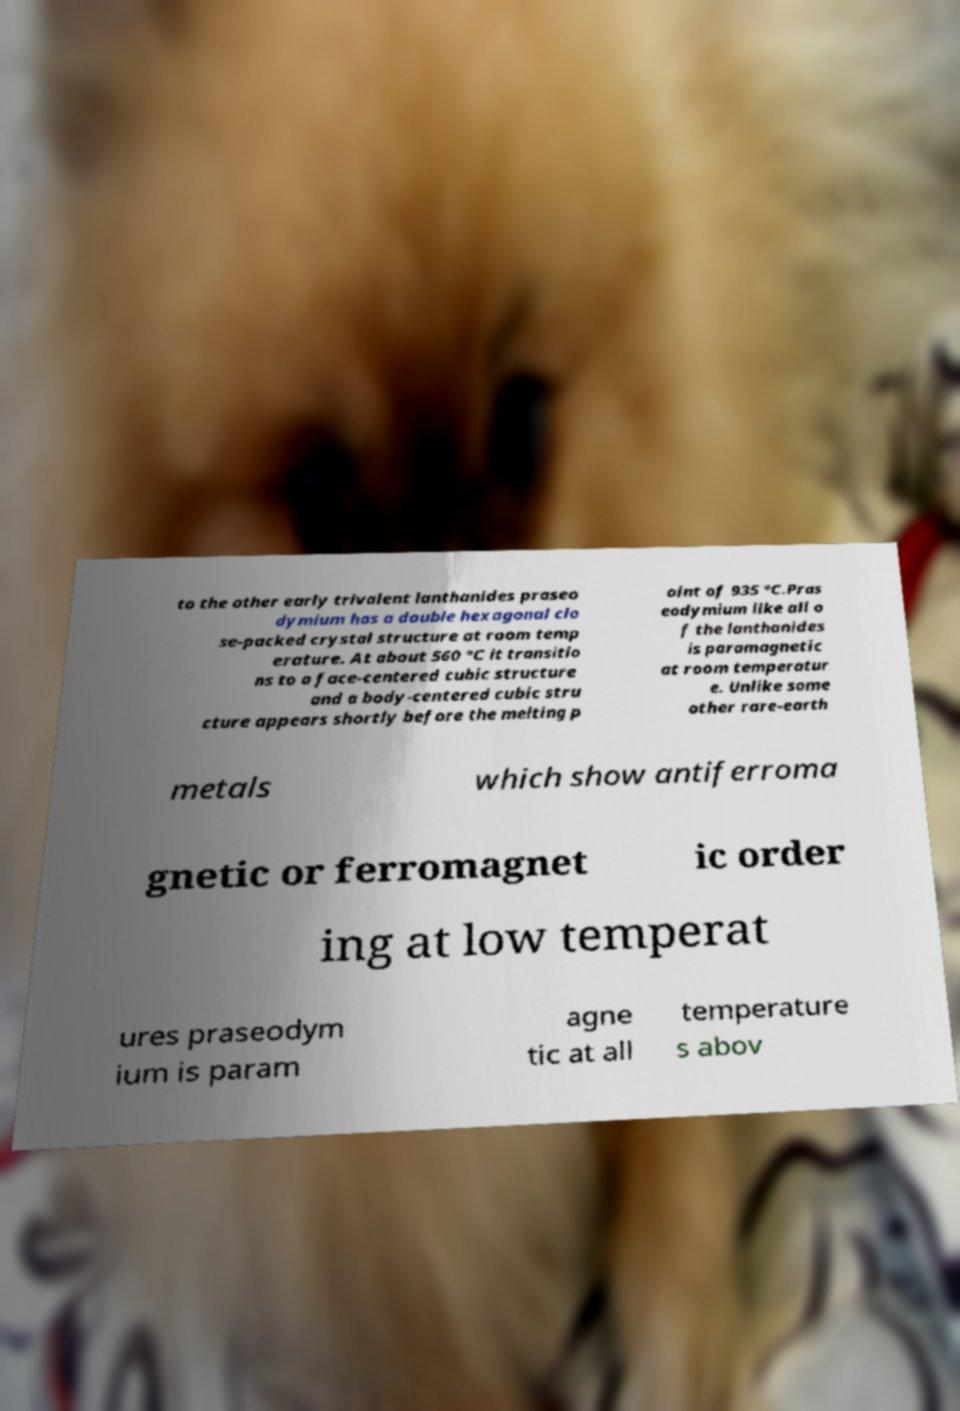Can you accurately transcribe the text from the provided image for me? to the other early trivalent lanthanides praseo dymium has a double hexagonal clo se-packed crystal structure at room temp erature. At about 560 °C it transitio ns to a face-centered cubic structure and a body-centered cubic stru cture appears shortly before the melting p oint of 935 °C.Pras eodymium like all o f the lanthanides is paramagnetic at room temperatur e. Unlike some other rare-earth metals which show antiferroma gnetic or ferromagnet ic order ing at low temperat ures praseodym ium is param agne tic at all temperature s abov 